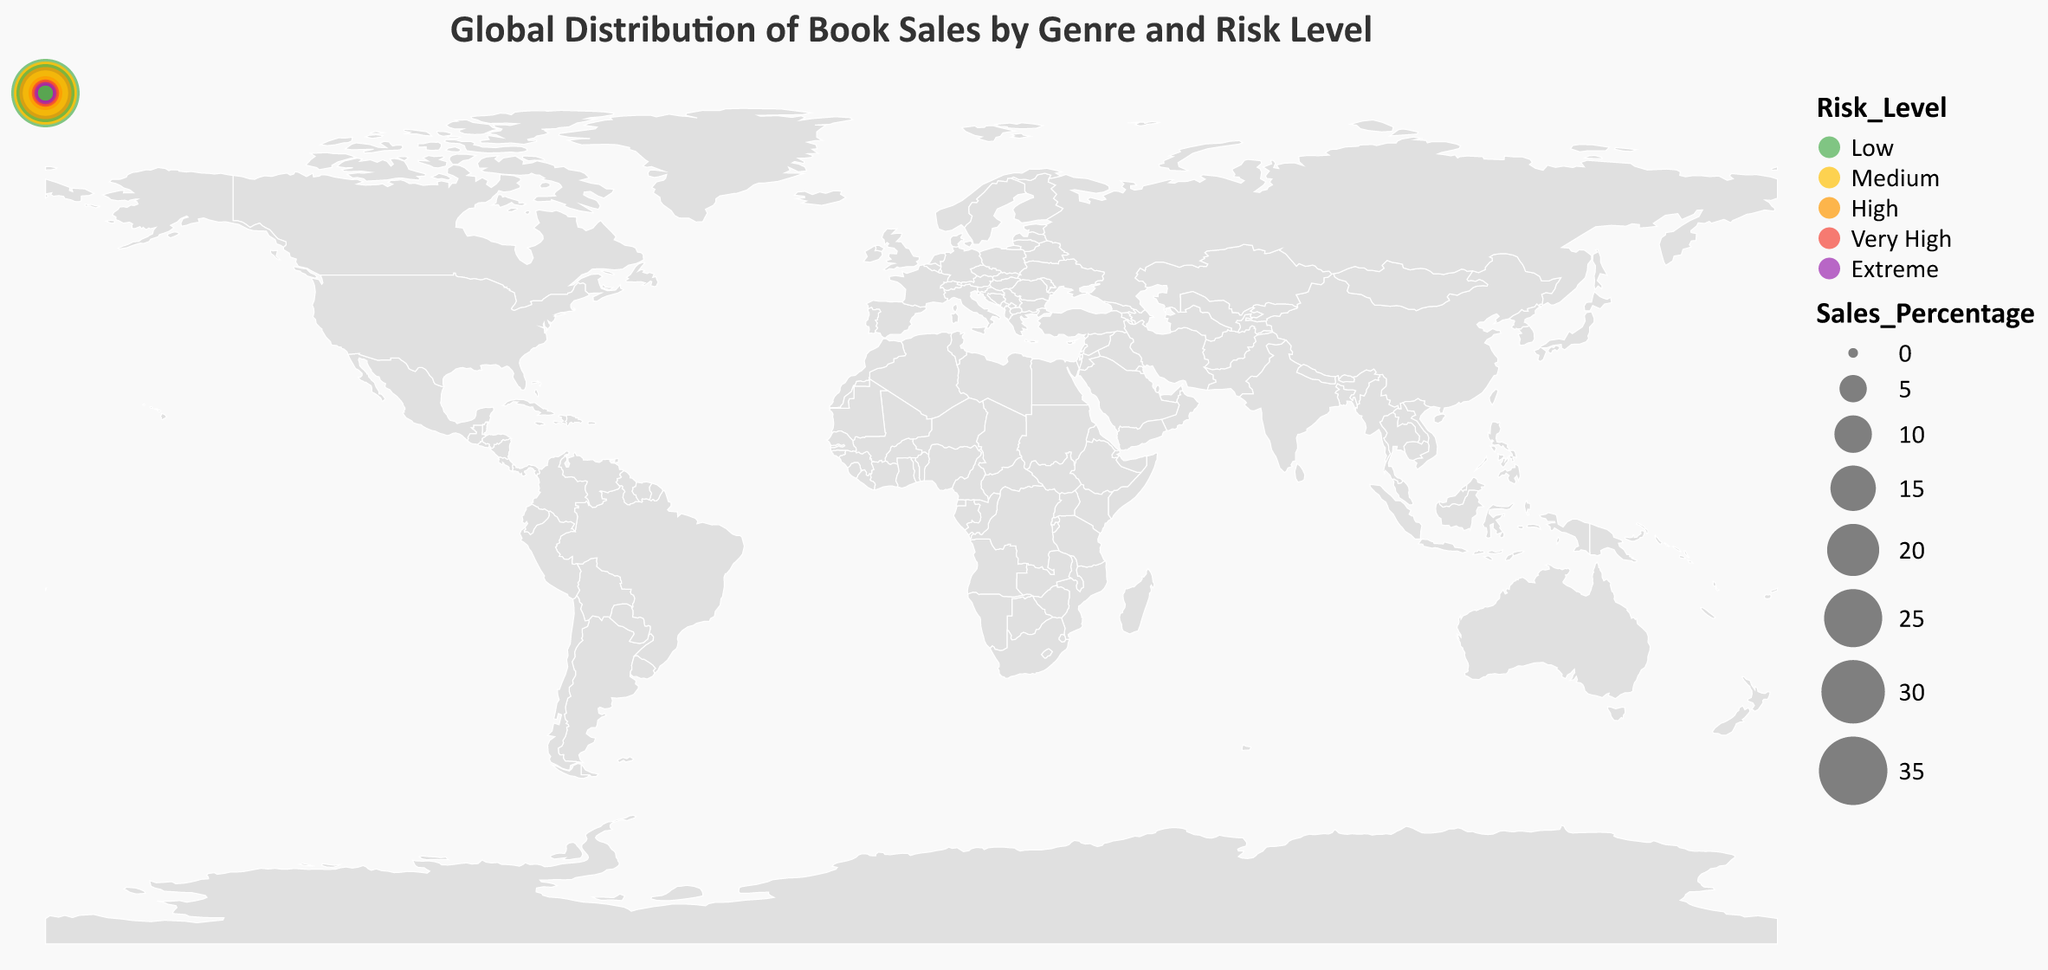Which region has the highest sales percentage for Fiction? The figure highlights book sales based on both genre and region. By examining the size and position of the circles representing Fiction sales, North America has the largest circle, indicating the highest sales percentage.
Answer: North America Which region has the lowest sales percentage for Non-Fiction? Looking for the smallest circle labeled as Non-Fiction, the Middle East region has the smallest value.
Answer: Middle East What is the combined sales percentage of Fiction in Africa and the Middle East? Adding the sales percentages for Fiction in Africa and the Middle East: 4% (Africa) + 2% (Middle East) = 6%.
Answer: 6% Compare the risk levels of Fiction and Non-Fiction books in Europe. Which is higher? Examining the colors representing risk levels in Europe, Fiction is marked with Medium risk (orange), and Non-Fiction with Low risk (green). So, Fiction has a higher risk level.
Answer: Fiction Which genre has a higher total sales percentage in Asia? The total sales in Asia for Fiction (20%) and Non-Fiction (15%). Thus, Fiction has a higher total sales percentage.
Answer: Fiction Which risk level is dominant in South America for Non-Fiction books? The color representing risk level for Non-Fiction in South America is Very High (red).
Answer: Very High Calculate the difference in sales percentage between Non-Fiction in North America and Europe. The Non-Fiction sales percentages are 28% for North America and 25% for Europe. The difference is 28% - 25% = 3%.
Answer: 3% Which regions have “Extreme” risk levels for any genre? The regions highlighted with the darkest color representing an extreme risk level are Africa (Non-Fiction) and the Middle East (Fiction).
Answer: Africa, Middle East Identify the region with the lowest overall risk for both Fiction and Non-Fiction genres. The regions with both Fiction and Non-Fiction genres marked as Low risk (green) are North America and Australia.
Answer: North America, Australia 